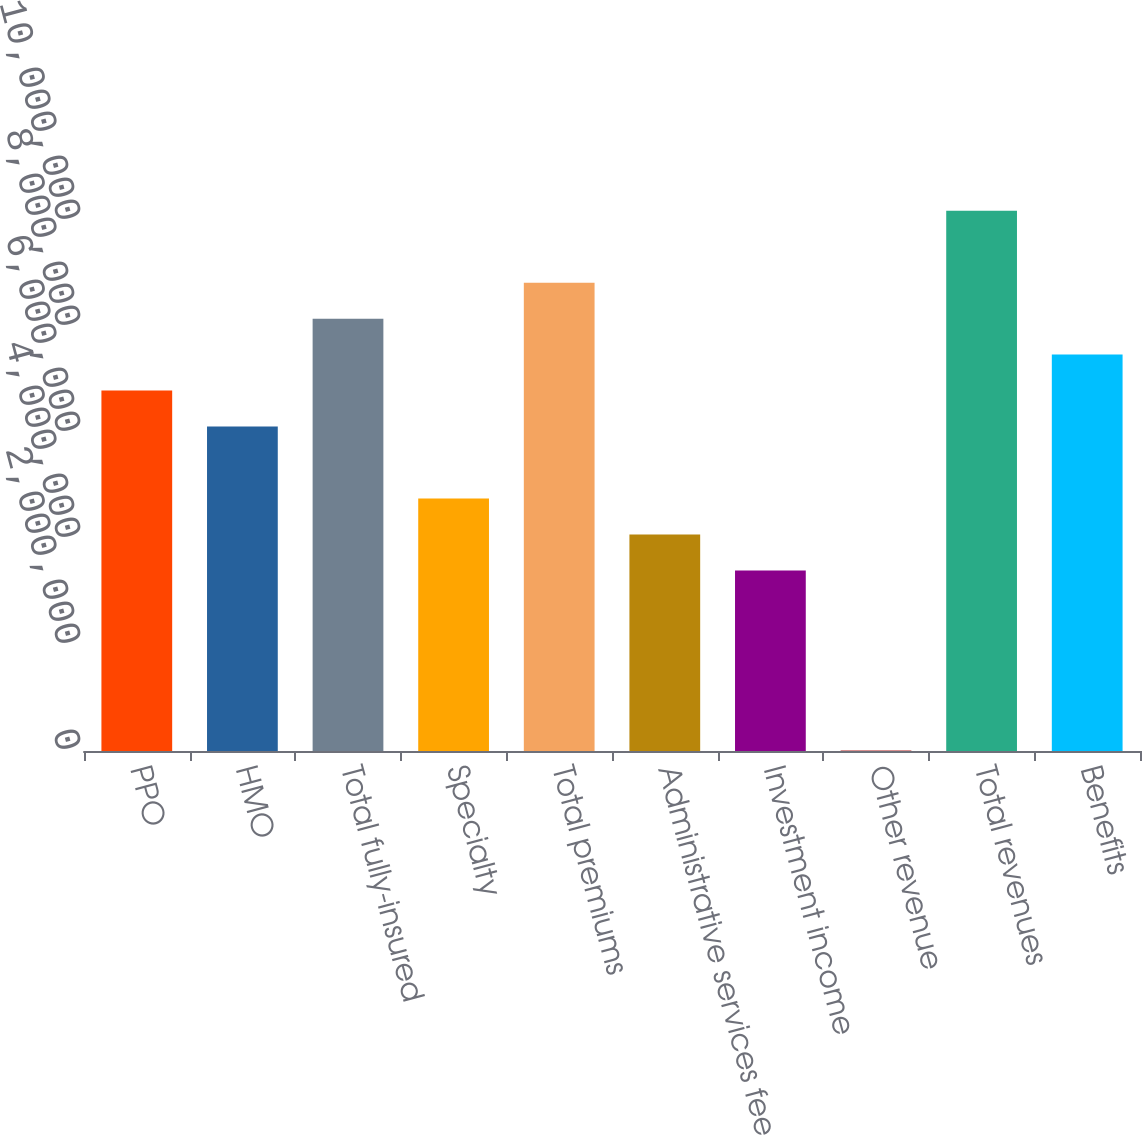Convert chart to OTSL. <chart><loc_0><loc_0><loc_500><loc_500><bar_chart><fcel>PPO<fcel>HMO<fcel>Total fully-insured<fcel>Specialty<fcel>Total premiums<fcel>Administrative services fees<fcel>Investment income<fcel>Other revenue<fcel>Total revenues<fcel>Benefits<nl><fcel>6.80022e+06<fcel>6.12132e+06<fcel>8.158e+06<fcel>4.76354e+06<fcel>8.8369e+06<fcel>4.08464e+06<fcel>3.40575e+06<fcel>11280<fcel>1.01947e+07<fcel>7.47911e+06<nl></chart> 